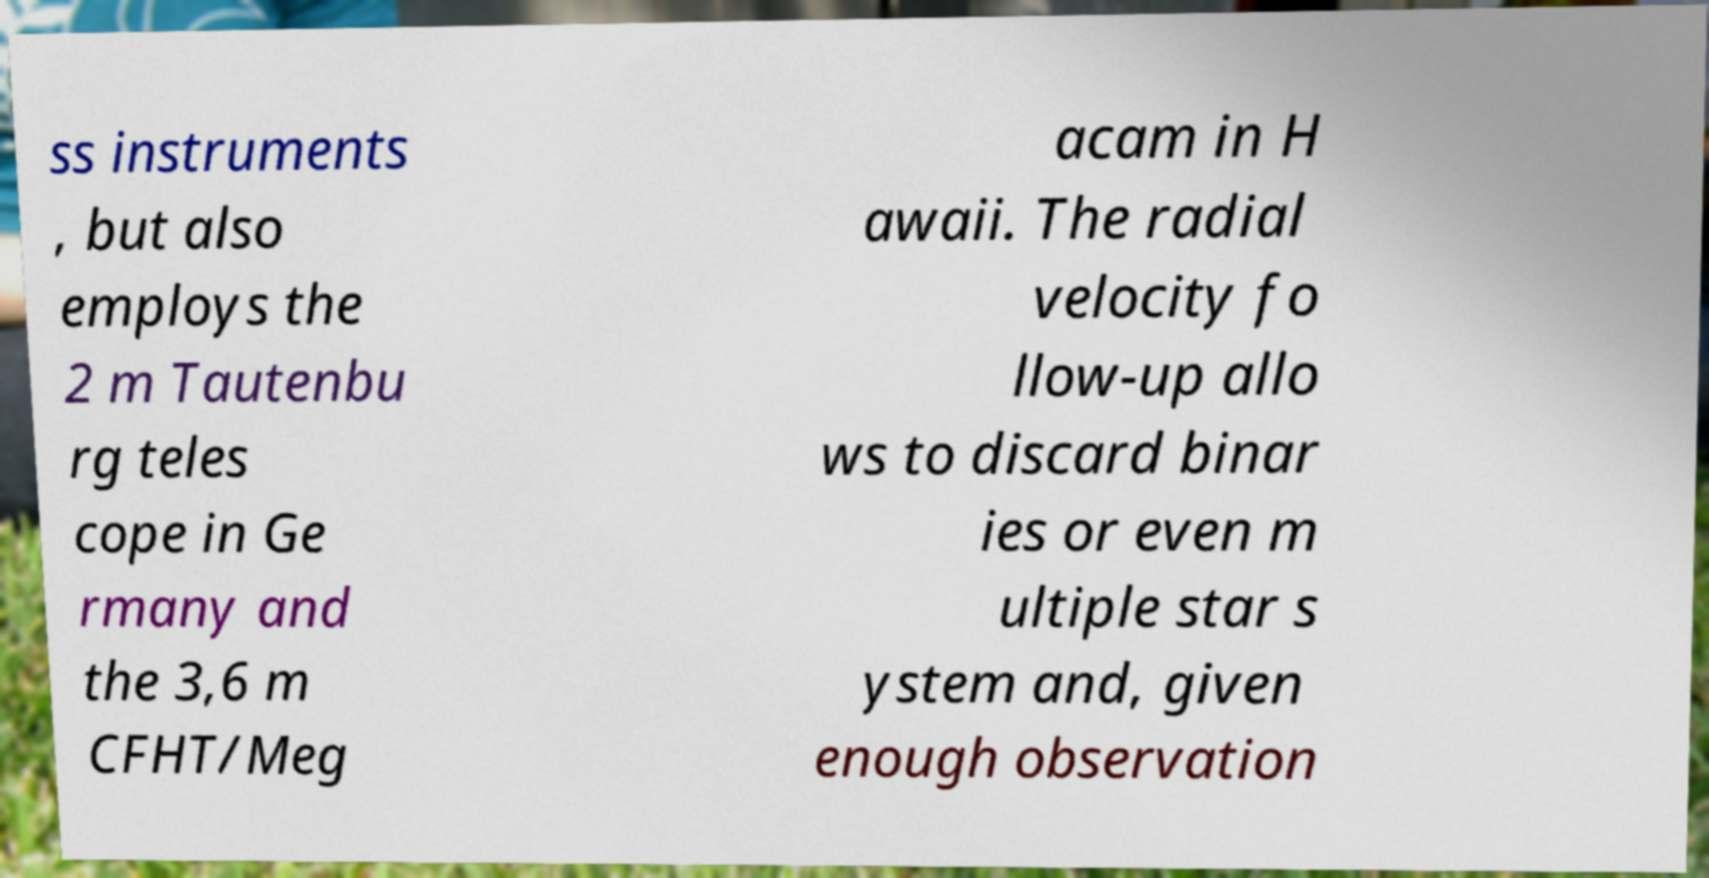What messages or text are displayed in this image? I need them in a readable, typed format. ss instruments , but also employs the 2 m Tautenbu rg teles cope in Ge rmany and the 3,6 m CFHT/Meg acam in H awaii. The radial velocity fo llow-up allo ws to discard binar ies or even m ultiple star s ystem and, given enough observation 